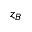Convert formula to latex. <formula><loc_0><loc_0><loc_500><loc_500>z _ { B }</formula> 